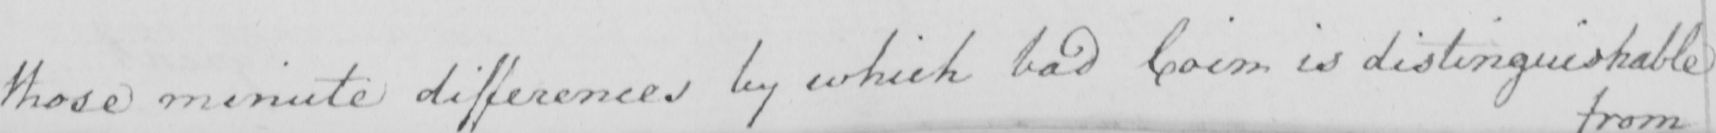Please transcribe the handwritten text in this image. those minute differences by which bad Coin is distinguishable 